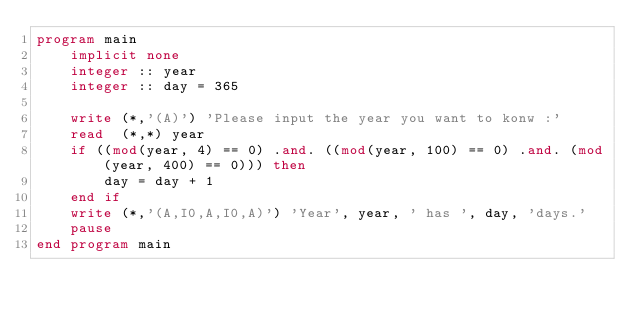Convert code to text. <code><loc_0><loc_0><loc_500><loc_500><_FORTRAN_>program main
	implicit none
	integer :: year
	integer :: day = 365
	
	write (*,'(A)') 'Please input the year you want to konw :'
	read  (*,*) year
	if ((mod(year, 4) == 0) .and. ((mod(year, 100) == 0) .and. (mod(year, 400) == 0))) then
		day = day + 1
	end if
	write (*,'(A,I0,A,I0,A)') 'Year', year, ' has ', day, 'days.'
	pause
end program main
</code> 